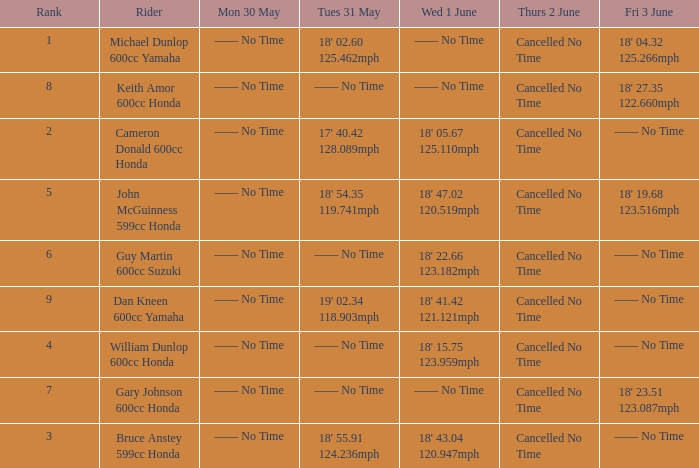What is the number of riders that had a Tues 31 May time of 18' 55.91 124.236mph? 1.0. 